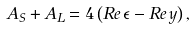Convert formula to latex. <formula><loc_0><loc_0><loc_500><loc_500>A _ { S } + A _ { L } = 4 \left ( R e \, \epsilon - R e \, y \right ) ,</formula> 